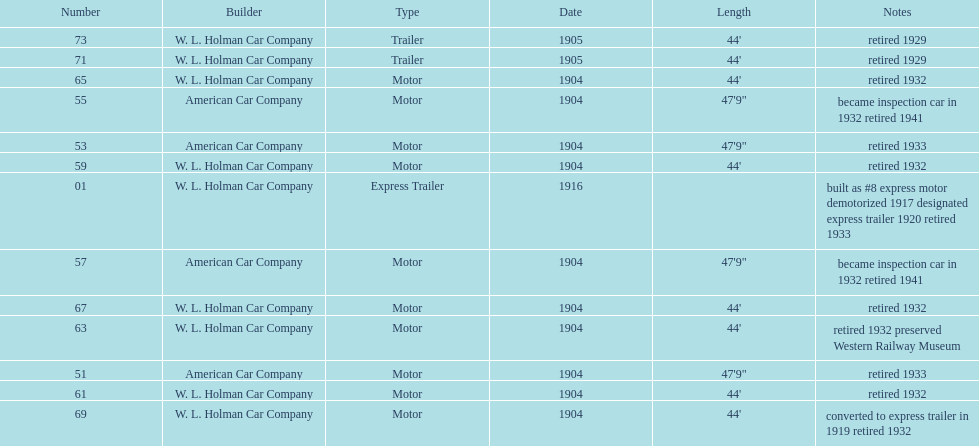In 1906, how many total rolling stock vehicles were in service? 12. 